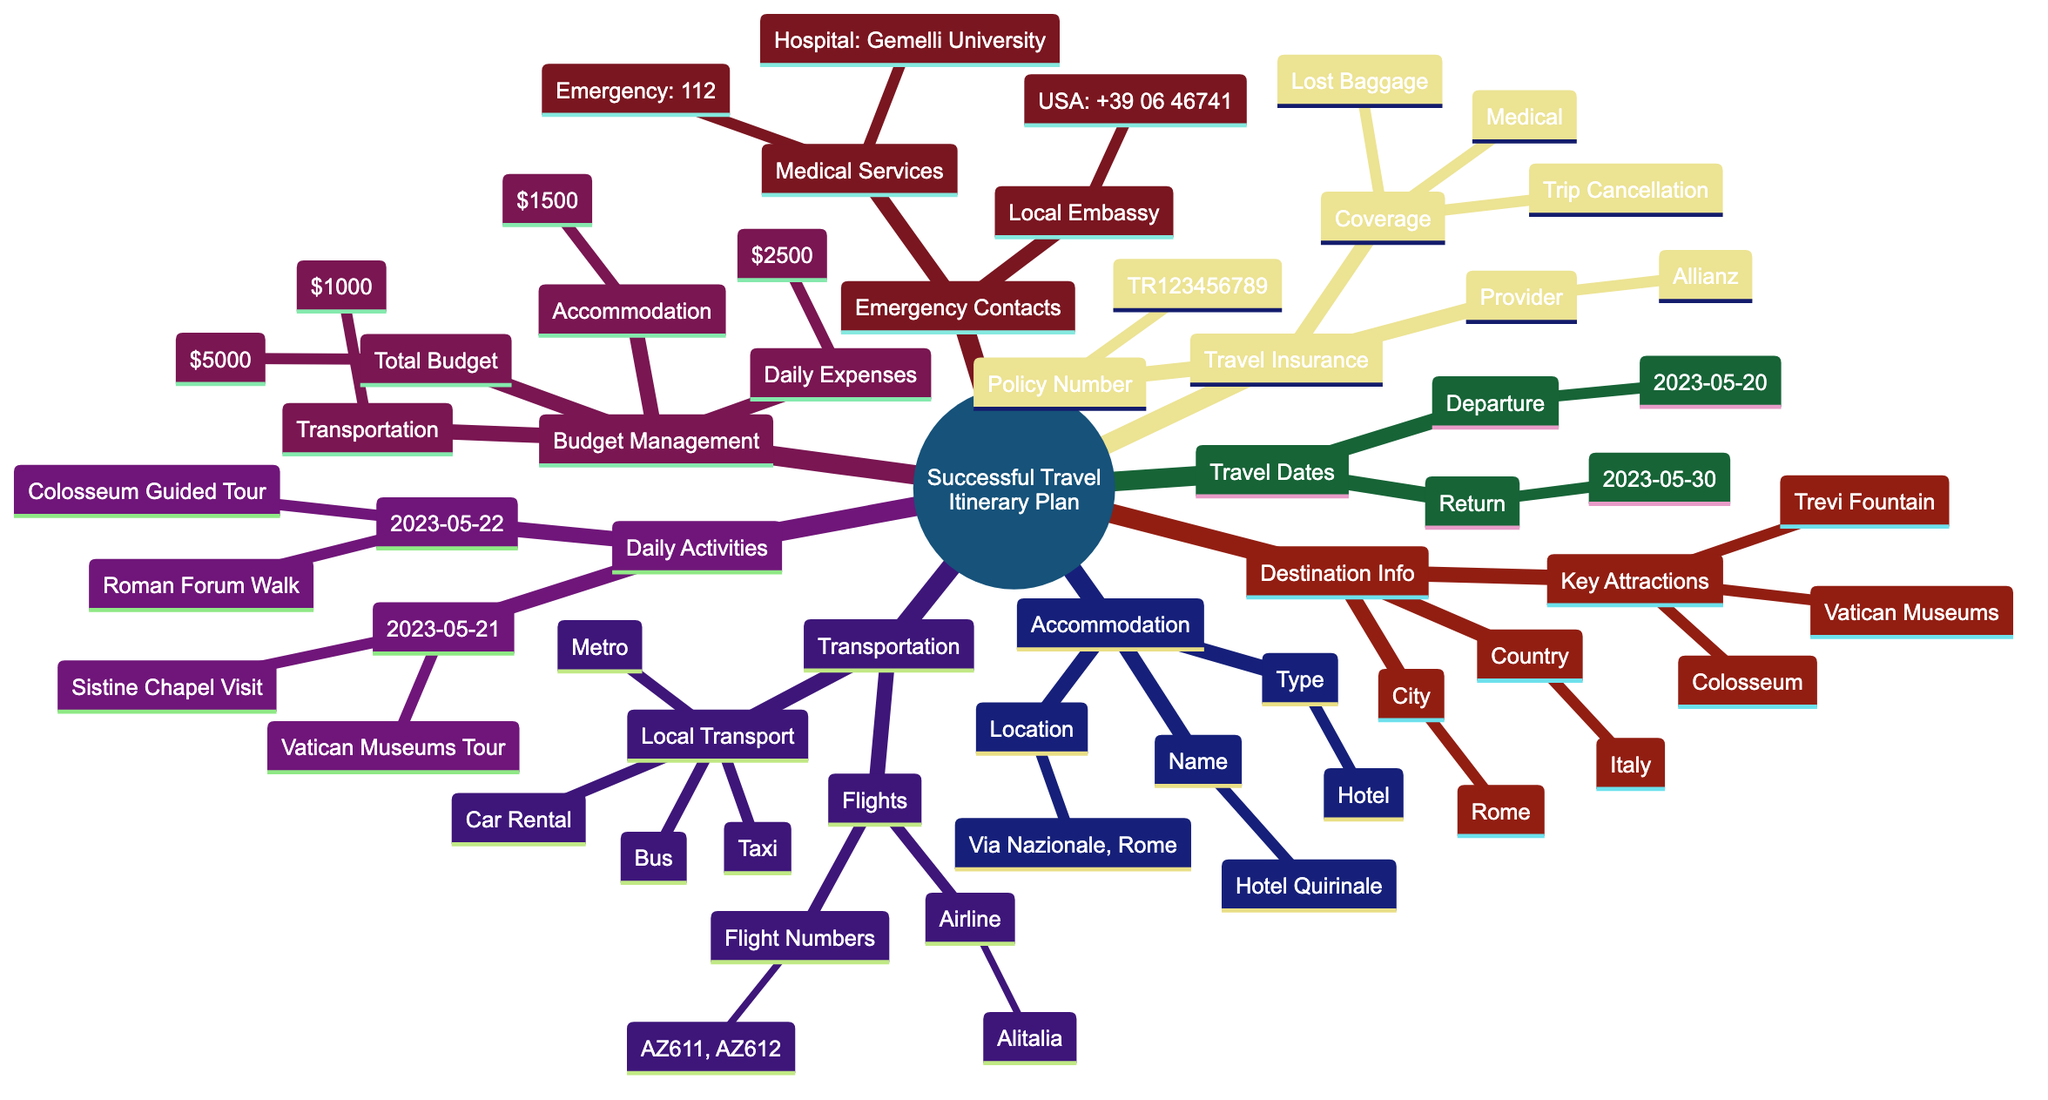What is the total budget allocated for the trip? The total budget can be found under the Budget Management section of the diagram, where it specifically states the Total Budget.
Answer: $5000 What is the name of the accommodation? To find the name of the accommodation, one can look under the Accommodation section, which specifies the Name attribute.
Answer: Hotel Quirinale Which city is the destination for the travel itinerary? The specific city for the travel itinerary is located within the Destination Information section, under the City node.
Answer: Rome How many daily activities are planned for May 21, 2023? By examining the Daily Activities section, the activities listed for May 21 can be counted to determine the total number. There are three activities listed.
Answer: 3 What local transport options are available? The Local Transport section outlines the different types of local transport available, presenting the options listed therein.
Answer: Metro, Bus, Taxi What is the coverage for the travel insurance? The Travel Insurance section provides details under Coverage, where multiple types of coverage are mentioned. All coverage types must be reviewed to respond correctly.
Answer: Medical Coverage, Trip Cancellation, Lost Baggage What departure airport is listed in the travel itinerary? The departure airport can be found by going to the Transportation section, specifically within the Flights information where Departure Airport is mentioned.
Answer: JFK Airport Who can be contacted at the local embassy? The Emergency Contacts section specifies who to reach out to at the local embassy by providing the Local Embassy node, which contains information about the country and contact number.
Answer: USA: +39 06 46741 What are the check-in and check-out dates for the accommodation? The Accommodation section outlines both the Check-In Date and Check-Out Date, providing the complete stay duration for the accommodation.
Answer: 2023-05-20, 2023-05-30 